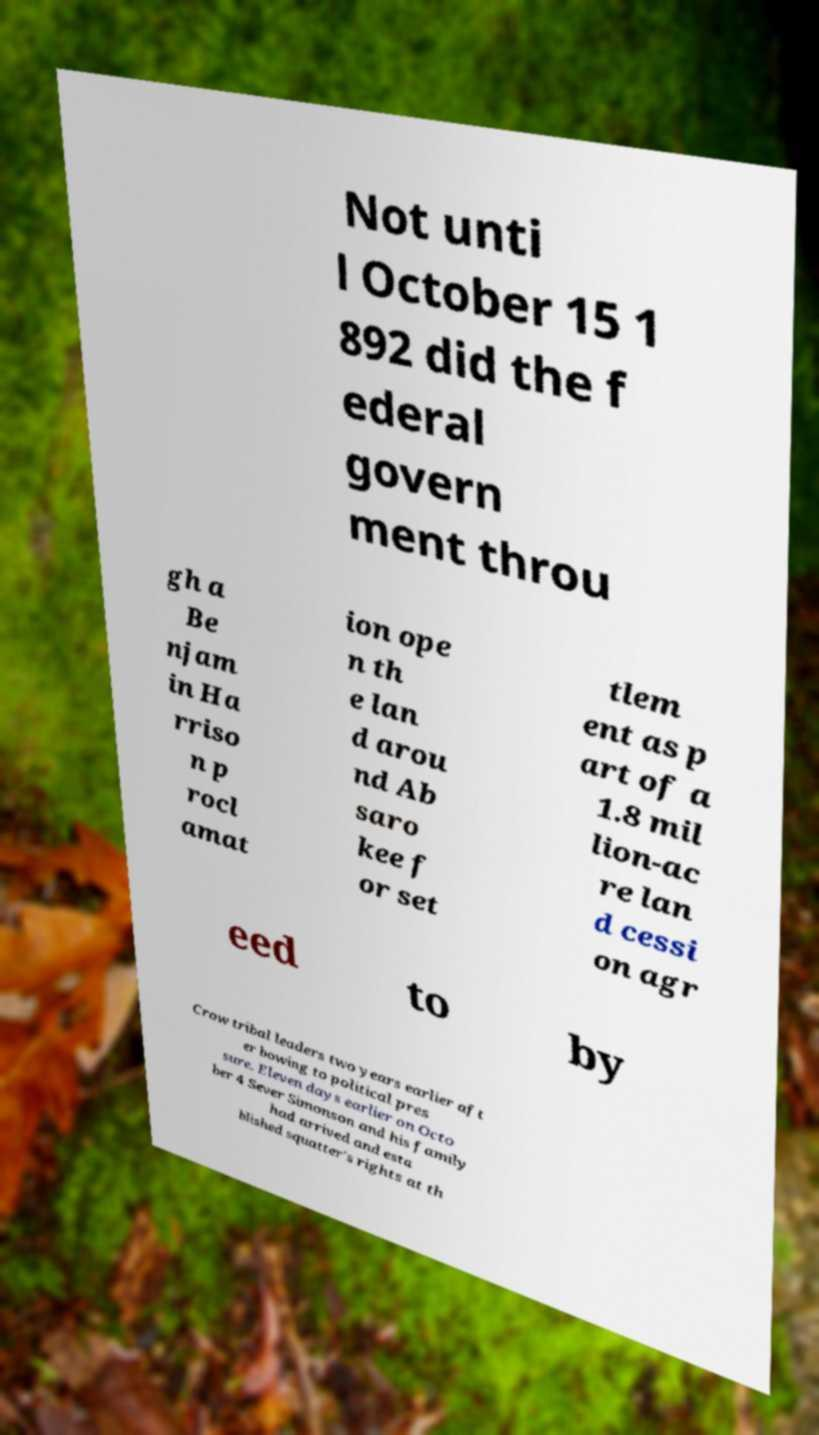There's text embedded in this image that I need extracted. Can you transcribe it verbatim? Not unti l October 15 1 892 did the f ederal govern ment throu gh a Be njam in Ha rriso n p rocl amat ion ope n th e lan d arou nd Ab saro kee f or set tlem ent as p art of a 1.8 mil lion-ac re lan d cessi on agr eed to by Crow tribal leaders two years earlier aft er bowing to political pres sure. Eleven days earlier on Octo ber 4 Sever Simonson and his family had arrived and esta blished squatter's rights at th 